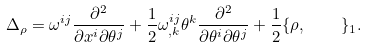Convert formula to latex. <formula><loc_0><loc_0><loc_500><loc_500>\Delta _ { \rho } = \omega ^ { i j } \frac { \partial ^ { 2 } } { \partial x ^ { i } \partial \theta ^ { j } } + \frac { 1 } { 2 } \omega _ { , k } ^ { i j } \theta ^ { k } \frac { \partial ^ { 2 } } { \partial \theta ^ { i } \partial \theta ^ { j } } + \frac { 1 } { 2 } \{ \rho , \quad \} _ { 1 } .</formula> 